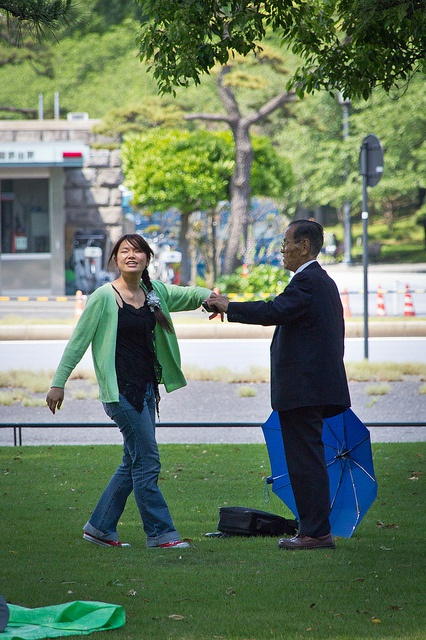Describe the objects in this image and their specific colors. I can see people in black, navy, teal, and turquoise tones, people in black, navy, gray, and white tones, umbrella in black, blue, navy, and darkblue tones, handbag in black, navy, blue, and teal tones, and stop sign in black, gray, and blue tones in this image. 